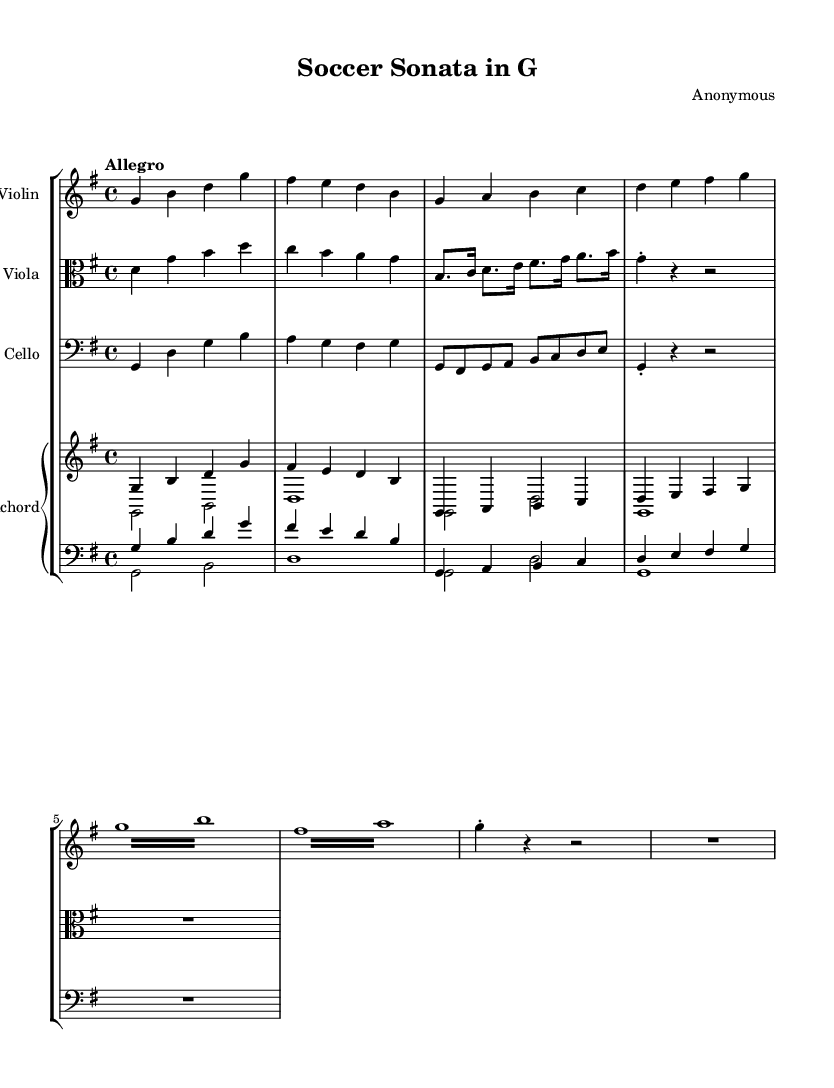What is the key signature of this music? The key signature is indicated at the beginning of the staff. In this sheet music, there is one sharp (F#), which means the key signature corresponds to G major.
Answer: G major What is the time signature of the piece? The time signature is located at the beginning of the music and is indicated by the numbers stacked one above the other. Here, it shows 4/4, meaning there are four beats in a measure and the quarter note receives one beat.
Answer: 4/4 What tempo marking is given? The tempo marking can be found near the top of the score, indicating the desired speed of the piece. In this case, it is marked "Allegro," suggesting a fast and lively tempo.
Answer: Allegro How many instruments are in the ensemble? The number of instruments can be counted by looking at the staff groupings. There are four separate staves for Violin, Viola, Cello, and Harpsichord, indicating that these are four distinct instruments.
Answer: Four What is the highest note shown in the violin part? To find the highest note, observe the staff for the violin part placed in the score. The highest note appears to be D, which is played in the third measure of the music.
Answer: D What type of ornamentation is used in this piece? Ornamentation can be identified by specific markings in the score. In the violin part, we see the term 'tremolo,' which indicates a rapid alternation of a note, suggesting an ornamental style characteristic of Baroque music.
Answer: Tremolo 